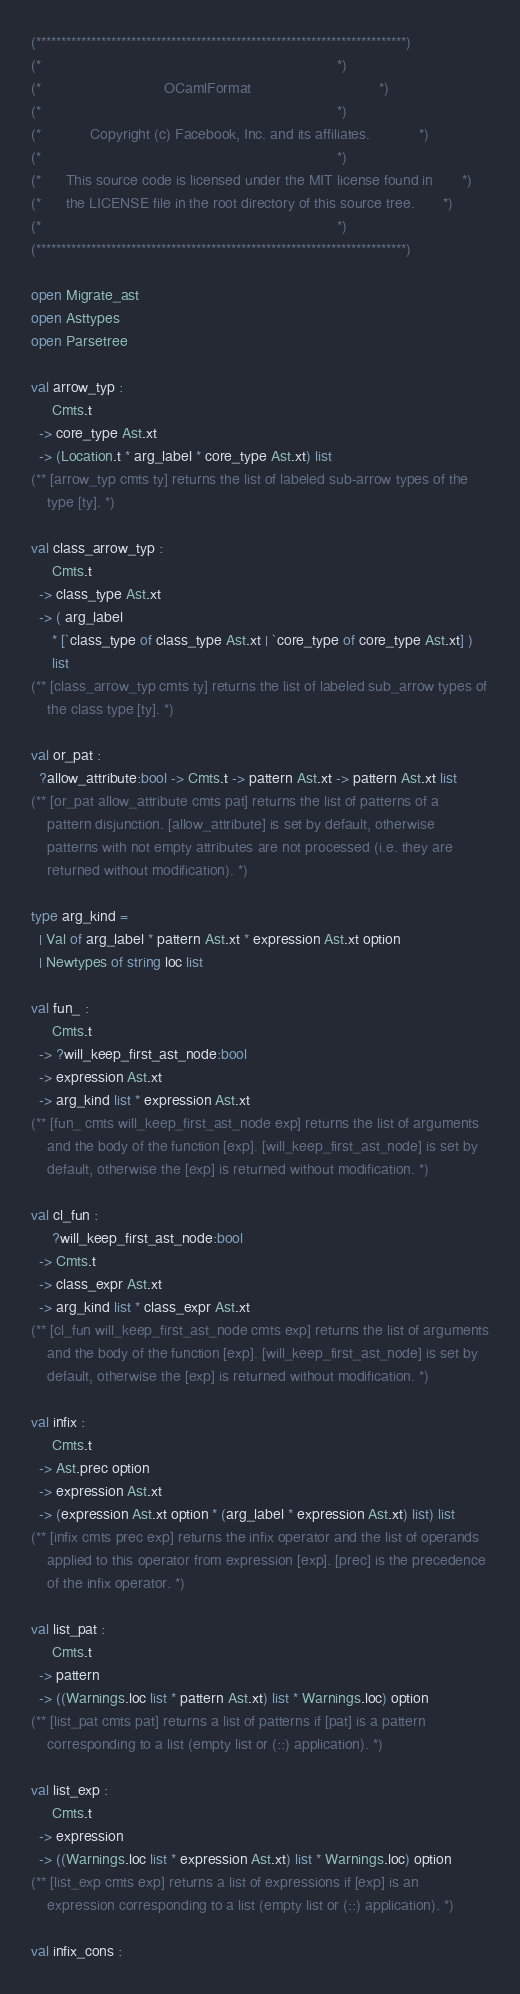Convert code to text. <code><loc_0><loc_0><loc_500><loc_500><_OCaml_>(**************************************************************************)
(*                                                                        *)
(*                              OCamlFormat                               *)
(*                                                                        *)
(*            Copyright (c) Facebook, Inc. and its affiliates.            *)
(*                                                                        *)
(*      This source code is licensed under the MIT license found in       *)
(*      the LICENSE file in the root directory of this source tree.       *)
(*                                                                        *)
(**************************************************************************)

open Migrate_ast
open Asttypes
open Parsetree

val arrow_typ :
     Cmts.t
  -> core_type Ast.xt
  -> (Location.t * arg_label * core_type Ast.xt) list
(** [arrow_typ cmts ty] returns the list of labeled sub-arrow types of the
    type [ty]. *)

val class_arrow_typ :
     Cmts.t
  -> class_type Ast.xt
  -> ( arg_label
     * [`class_type of class_type Ast.xt | `core_type of core_type Ast.xt] )
     list
(** [class_arrow_typ cmts ty] returns the list of labeled sub_arrow types of
    the class type [ty]. *)

val or_pat :
  ?allow_attribute:bool -> Cmts.t -> pattern Ast.xt -> pattern Ast.xt list
(** [or_pat allow_attribute cmts pat] returns the list of patterns of a
    pattern disjunction. [allow_attribute] is set by default, otherwise
    patterns with not empty attributes are not processed (i.e. they are
    returned without modification). *)

type arg_kind =
  | Val of arg_label * pattern Ast.xt * expression Ast.xt option
  | Newtypes of string loc list

val fun_ :
     Cmts.t
  -> ?will_keep_first_ast_node:bool
  -> expression Ast.xt
  -> arg_kind list * expression Ast.xt
(** [fun_ cmts will_keep_first_ast_node exp] returns the list of arguments
    and the body of the function [exp]. [will_keep_first_ast_node] is set by
    default, otherwise the [exp] is returned without modification. *)

val cl_fun :
     ?will_keep_first_ast_node:bool
  -> Cmts.t
  -> class_expr Ast.xt
  -> arg_kind list * class_expr Ast.xt
(** [cl_fun will_keep_first_ast_node cmts exp] returns the list of arguments
    and the body of the function [exp]. [will_keep_first_ast_node] is set by
    default, otherwise the [exp] is returned without modification. *)

val infix :
     Cmts.t
  -> Ast.prec option
  -> expression Ast.xt
  -> (expression Ast.xt option * (arg_label * expression Ast.xt) list) list
(** [infix cmts prec exp] returns the infix operator and the list of operands
    applied to this operator from expression [exp]. [prec] is the precedence
    of the infix operator. *)

val list_pat :
     Cmts.t
  -> pattern
  -> ((Warnings.loc list * pattern Ast.xt) list * Warnings.loc) option
(** [list_pat cmts pat] returns a list of patterns if [pat] is a pattern
    corresponding to a list (empty list or (::) application). *)

val list_exp :
     Cmts.t
  -> expression
  -> ((Warnings.loc list * expression Ast.xt) list * Warnings.loc) option
(** [list_exp cmts exp] returns a list of expressions if [exp] is an
    expression corresponding to a list (empty list or (::) application). *)

val infix_cons :</code> 